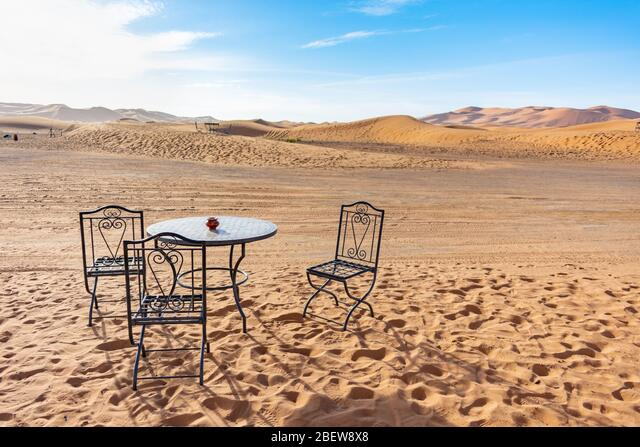What time of day does it appear to be in the image? Based on the lighting and shadows, it seems to be midday or early afternoon. The sun is casting short shadows, indicating that it's at a high point in the sky. 